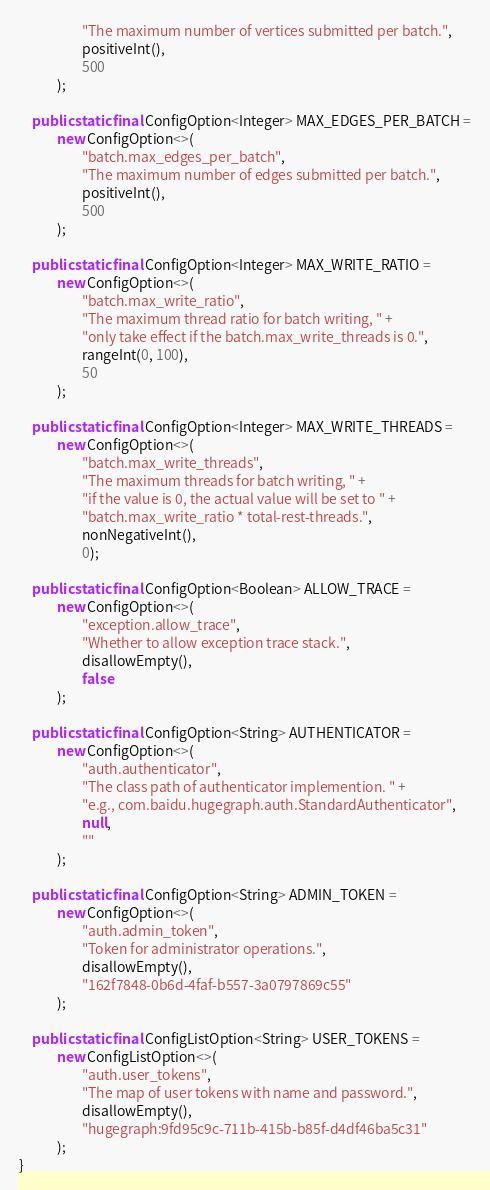Convert code to text. <code><loc_0><loc_0><loc_500><loc_500><_Java_>                    "The maximum number of vertices submitted per batch.",
                    positiveInt(),
                    500
            );

    public static final ConfigOption<Integer> MAX_EDGES_PER_BATCH =
            new ConfigOption<>(
                    "batch.max_edges_per_batch",
                    "The maximum number of edges submitted per batch.",
                    positiveInt(),
                    500
            );

    public static final ConfigOption<Integer> MAX_WRITE_RATIO =
            new ConfigOption<>(
                    "batch.max_write_ratio",
                    "The maximum thread ratio for batch writing, " +
                    "only take effect if the batch.max_write_threads is 0.",
                    rangeInt(0, 100),
                    50
            );

    public static final ConfigOption<Integer> MAX_WRITE_THREADS =
            new ConfigOption<>(
                    "batch.max_write_threads",
                    "The maximum threads for batch writing, " +
                    "if the value is 0, the actual value will be set to " +
                    "batch.max_write_ratio * total-rest-threads.",
                    nonNegativeInt(),
                    0);

    public static final ConfigOption<Boolean> ALLOW_TRACE =
            new ConfigOption<>(
                    "exception.allow_trace",
                    "Whether to allow exception trace stack.",
                    disallowEmpty(),
                    false
            );

    public static final ConfigOption<String> AUTHENTICATOR =
            new ConfigOption<>(
                    "auth.authenticator",
                    "The class path of authenticator implemention. " +
                    "e.g., com.baidu.hugegraph.auth.StandardAuthenticator",
                    null,
                    ""
            );

    public static final ConfigOption<String> ADMIN_TOKEN =
            new ConfigOption<>(
                    "auth.admin_token",
                    "Token for administrator operations.",
                    disallowEmpty(),
                    "162f7848-0b6d-4faf-b557-3a0797869c55"
            );

    public static final ConfigListOption<String> USER_TOKENS =
            new ConfigListOption<>(
                    "auth.user_tokens",
                    "The map of user tokens with name and password.",
                    disallowEmpty(),
                    "hugegraph:9fd95c9c-711b-415b-b85f-d4df46ba5c31"
            );
}
</code> 